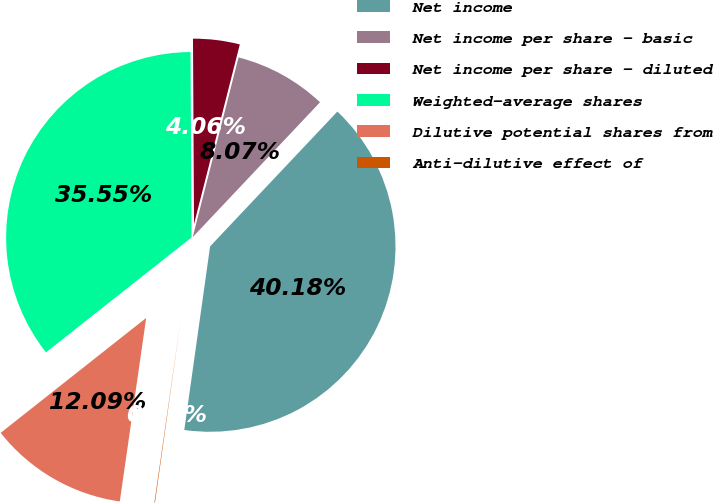Convert chart. <chart><loc_0><loc_0><loc_500><loc_500><pie_chart><fcel>Net income<fcel>Net income per share - basic<fcel>Net income per share - diluted<fcel>Weighted-average shares<fcel>Dilutive potential shares from<fcel>Anti-dilutive effect of<nl><fcel>40.18%<fcel>8.07%<fcel>4.06%<fcel>35.55%<fcel>12.09%<fcel>0.05%<nl></chart> 